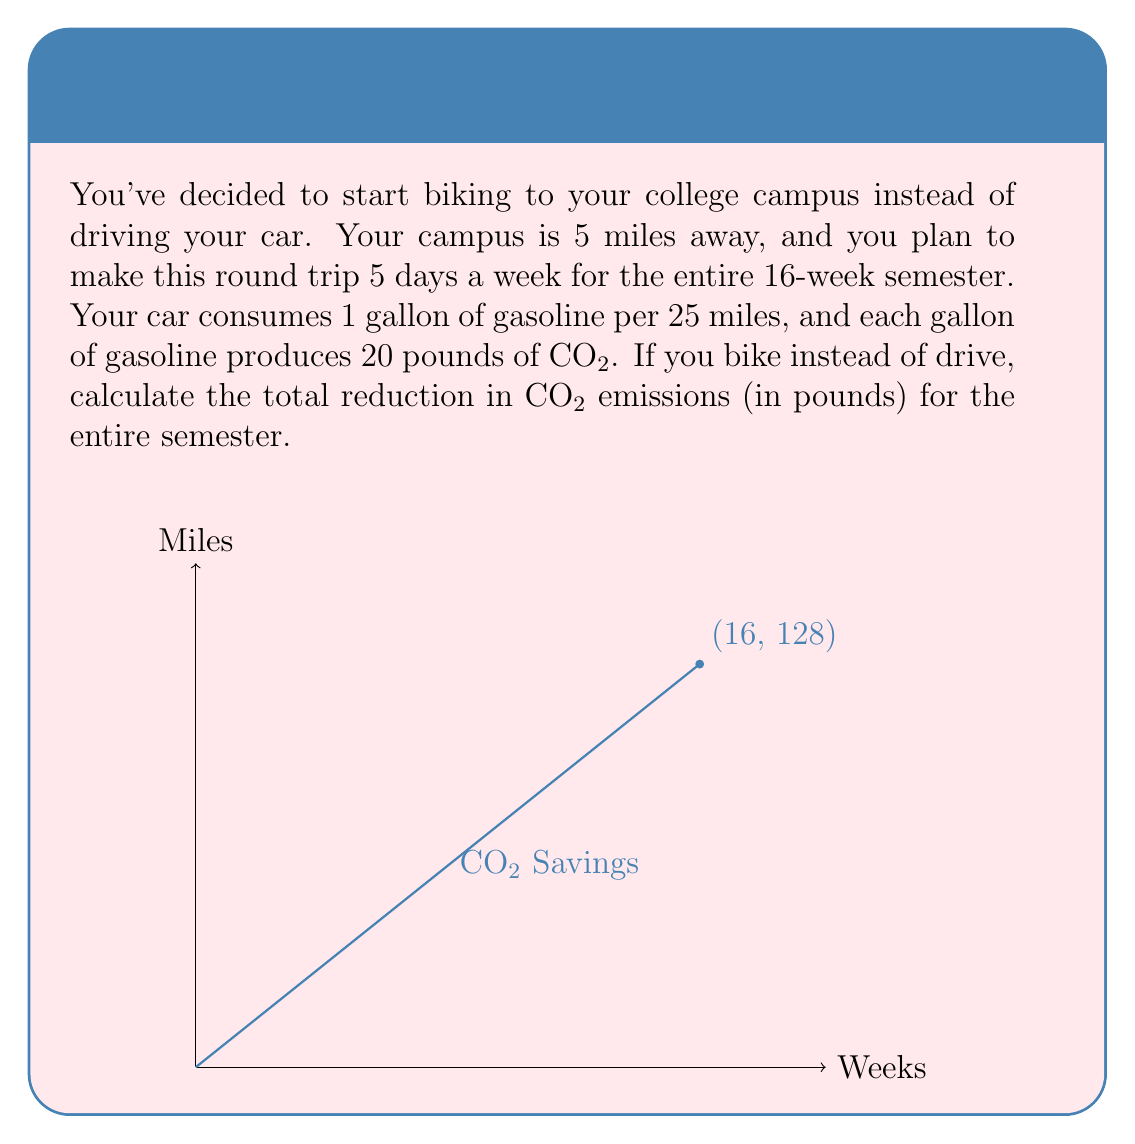Provide a solution to this math problem. Let's break this down step-by-step:

1) First, calculate the total distance traveled in a semester:
   - Round trip distance: $5 \text{ miles} \times 2 = 10 \text{ miles per day}$
   - Weekly distance: $10 \text{ miles} \times 5 \text{ days} = 50 \text{ miles per week}$
   - Semester distance: $50 \text{ miles} \times 16 \text{ weeks} = 800 \text{ miles}$

2) Calculate how many gallons of gasoline would be used for this distance:
   $$\text{Gallons used} = \frac{800 \text{ miles}}{25 \text{ miles per gallon}} = 32 \text{ gallons}$$

3) Calculate the CO2 emissions from this amount of gasoline:
   $$\text{CO2 emissions} = 32 \text{ gallons} \times 20 \text{ pounds per gallon} = 640 \text{ pounds}$$

4) Therefore, by biking instead of driving, you would reduce CO2 emissions by 640 pounds over the course of the semester.

The graph shows the accumulation of CO2 savings over the 16-week semester, with the final point (16, 128) representing 16 weeks and 128 pounds of CO2 saved per week (640 pounds / 5 weeks).
Answer: 640 pounds 